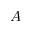<formula> <loc_0><loc_0><loc_500><loc_500>A</formula> 